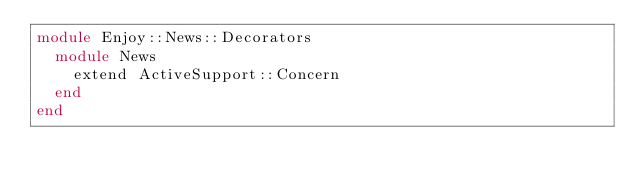Convert code to text. <code><loc_0><loc_0><loc_500><loc_500><_Ruby_>module Enjoy::News::Decorators
  module News
    extend ActiveSupport::Concern
  end
end
</code> 